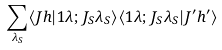Convert formula to latex. <formula><loc_0><loc_0><loc_500><loc_500>\sum _ { \lambda _ { S } } \langle J h | 1 \lambda ; J _ { S } \lambda _ { S } \rangle \langle 1 \lambda ; J _ { S } \lambda _ { S } | J ^ { \prime } h ^ { \prime } \rangle</formula> 